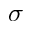Convert formula to latex. <formula><loc_0><loc_0><loc_500><loc_500>\sigma</formula> 